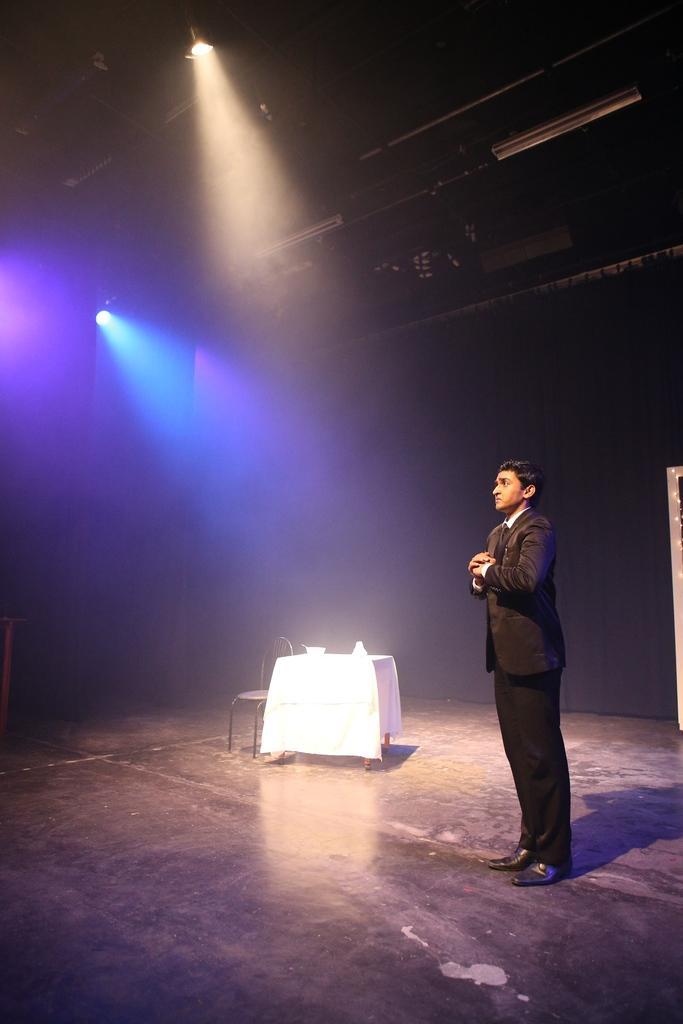How would you summarize this image in a sentence or two? In this picture we can see a man in the black blazer is standing, and behind the man there is a chair and a table covered with a cloth. Behind the table there is a dark background and the lights. 